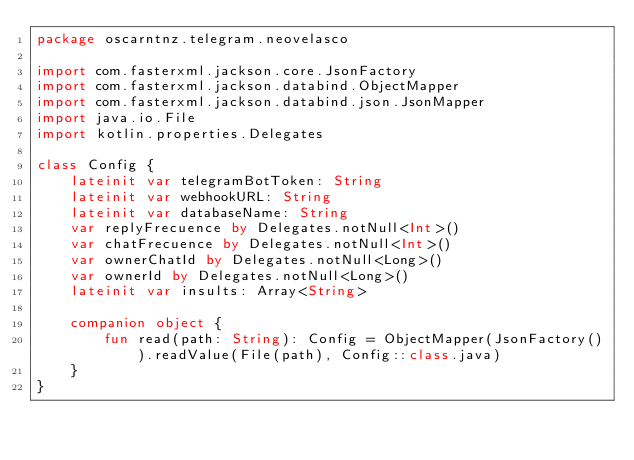<code> <loc_0><loc_0><loc_500><loc_500><_Kotlin_>package oscarntnz.telegram.neovelasco

import com.fasterxml.jackson.core.JsonFactory
import com.fasterxml.jackson.databind.ObjectMapper
import com.fasterxml.jackson.databind.json.JsonMapper
import java.io.File
import kotlin.properties.Delegates

class Config {
    lateinit var telegramBotToken: String
    lateinit var webhookURL: String
    lateinit var databaseName: String
    var replyFrecuence by Delegates.notNull<Int>()
    var chatFrecuence by Delegates.notNull<Int>()
    var ownerChatId by Delegates.notNull<Long>()
    var ownerId by Delegates.notNull<Long>()
    lateinit var insults: Array<String>

    companion object {
        fun read(path: String): Config = ObjectMapper(JsonFactory()).readValue(File(path), Config::class.java)
    }
}
</code> 